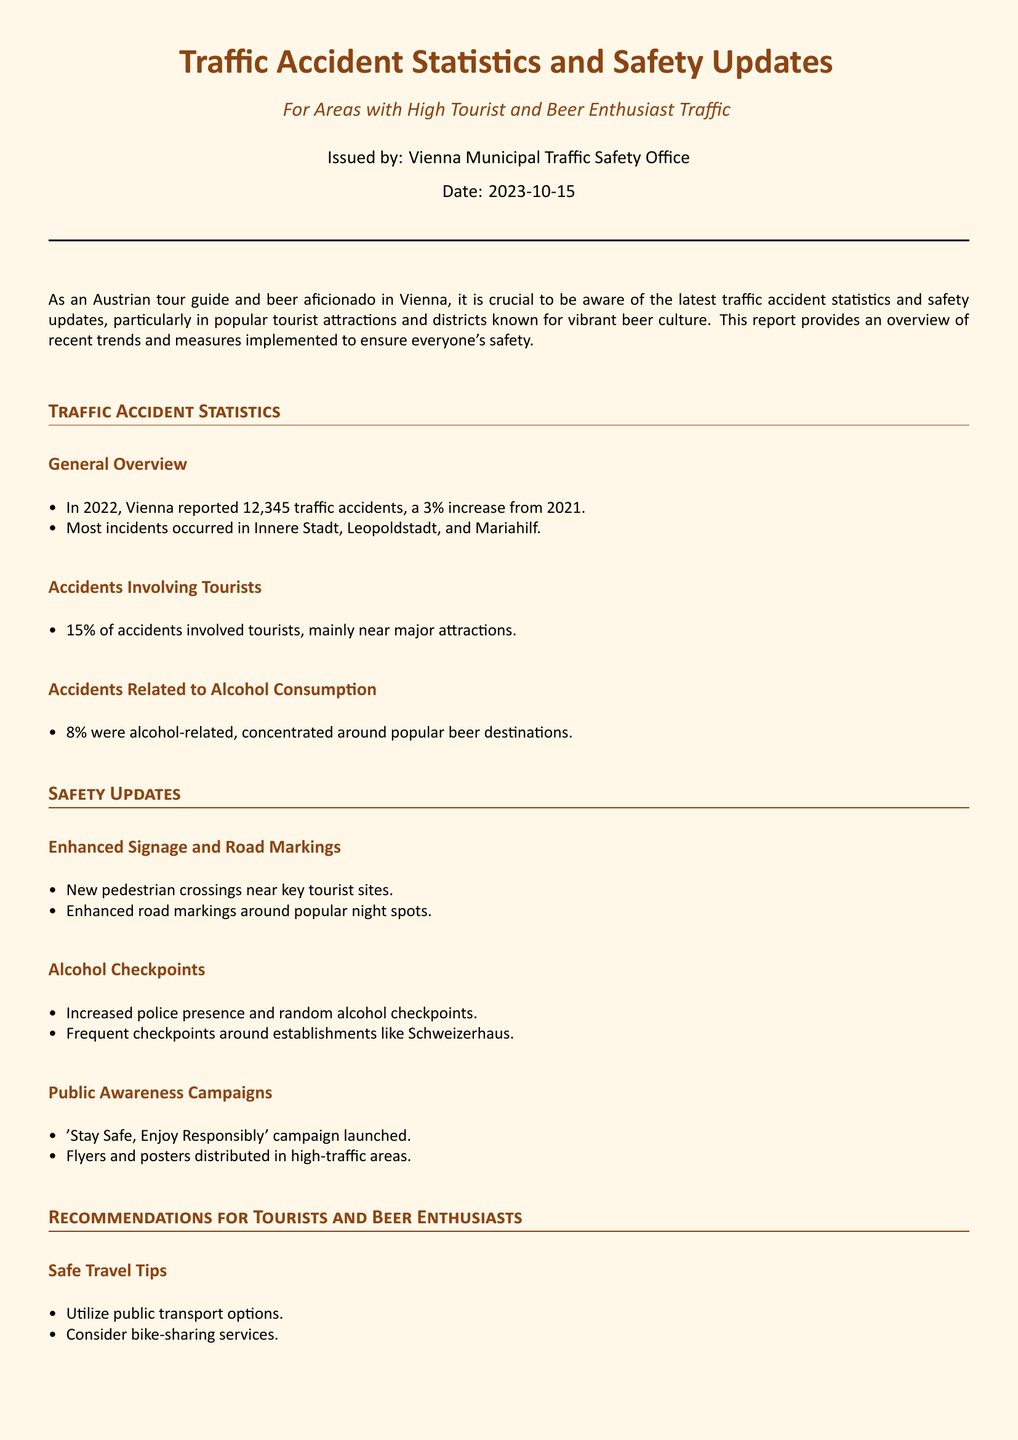what was the total number of traffic accidents in 2022? The total number of traffic accidents reported in Vienna in 2022 was 12,345, which is stated in the General Overview section.
Answer: 12,345 what percentage of accidents involved tourists? According to the Accidents Involving Tourists section, 15% of the accidents involved tourists.
Answer: 15% which districts had the most incidents? The districts with the most incidents, as mentioned in the report, are Innere Stadt, Leopoldstadt, and Mariahilf.
Answer: Innere Stadt, Leopoldstadt, Mariahilf what percentage of accidents were alcohol-related? The report states that 8% of accidents were alcohol-related, which is specified in the Accidents Related to Alcohol Consumption section.
Answer: 8% what new safety measure was introduced near key tourist sites? The report mentions new pedestrian crossings implemented near key tourist sites, as outlined in the Enhanced Signage and Road Markings section.
Answer: New pedestrian crossings how are alcohol checkpoints being addressed? Increased police presence and random alcohol checkpoints are stated in the Alcohol Checkpoints section as a method to address alcohol-related accidents.
Answer: Increased police presence what is the name of the public awareness campaign launched? The campaign is called 'Stay Safe, Enjoy Responsibly' as mentioned in the Public Awareness Campaigns section of the report.
Answer: 'Stay Safe, Enjoy Responsibly' what safe travel option is recommended for tourists? The report recommends utilizing public transport options as a safe travel tip in the Recommendations for Tourists and Beer Enthusiasts section.
Answer: Public transport options what is one suggestion for responsible drinking? One suggestion mentioned in the Responsible Drinking section is to plan ahead with a designated driver or use ride-sharing apps.
Answer: Designated driver or ride-sharing apps 